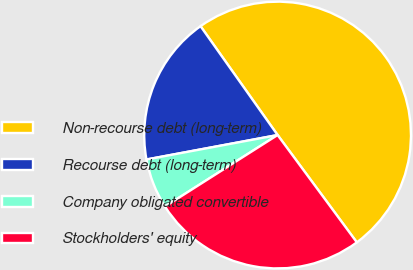<chart> <loc_0><loc_0><loc_500><loc_500><pie_chart><fcel>Non-recourse debt (long-term)<fcel>Recourse debt (long-term)<fcel>Company obligated convertible<fcel>Stockholders' equity<nl><fcel>49.69%<fcel>18.13%<fcel>6.07%<fcel>26.12%<nl></chart> 